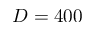Convert formula to latex. <formula><loc_0><loc_0><loc_500><loc_500>D = 4 0 0</formula> 